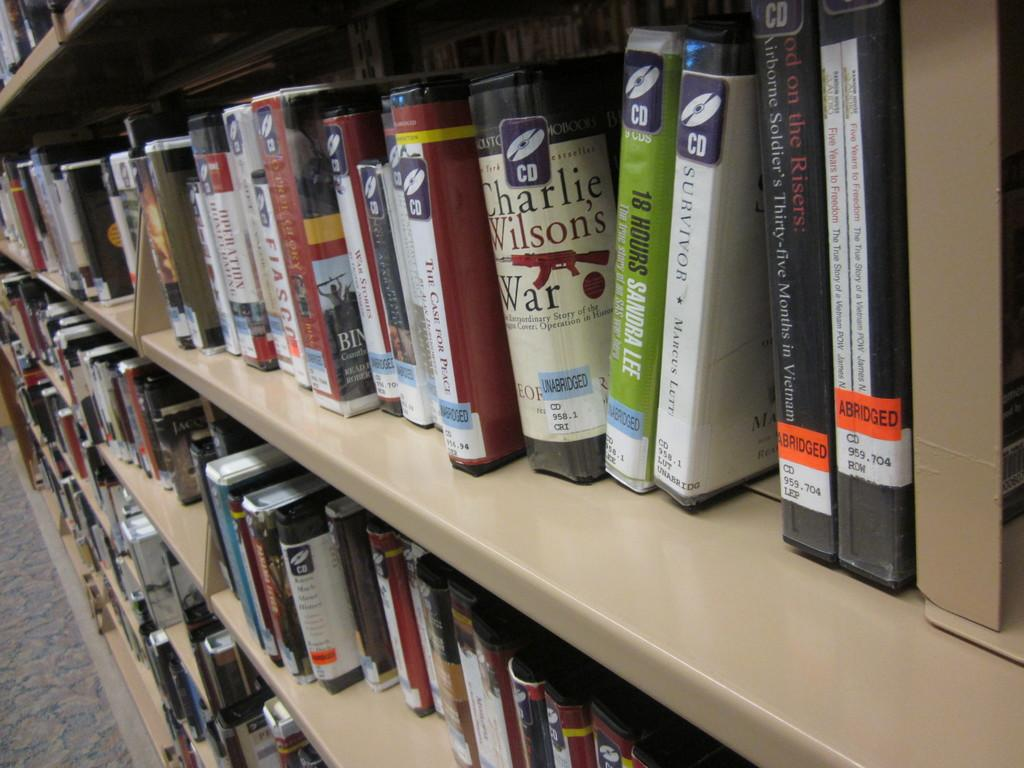<image>
Provide a brief description of the given image. Book by Charlie Wilson in between other books on a shelf. 